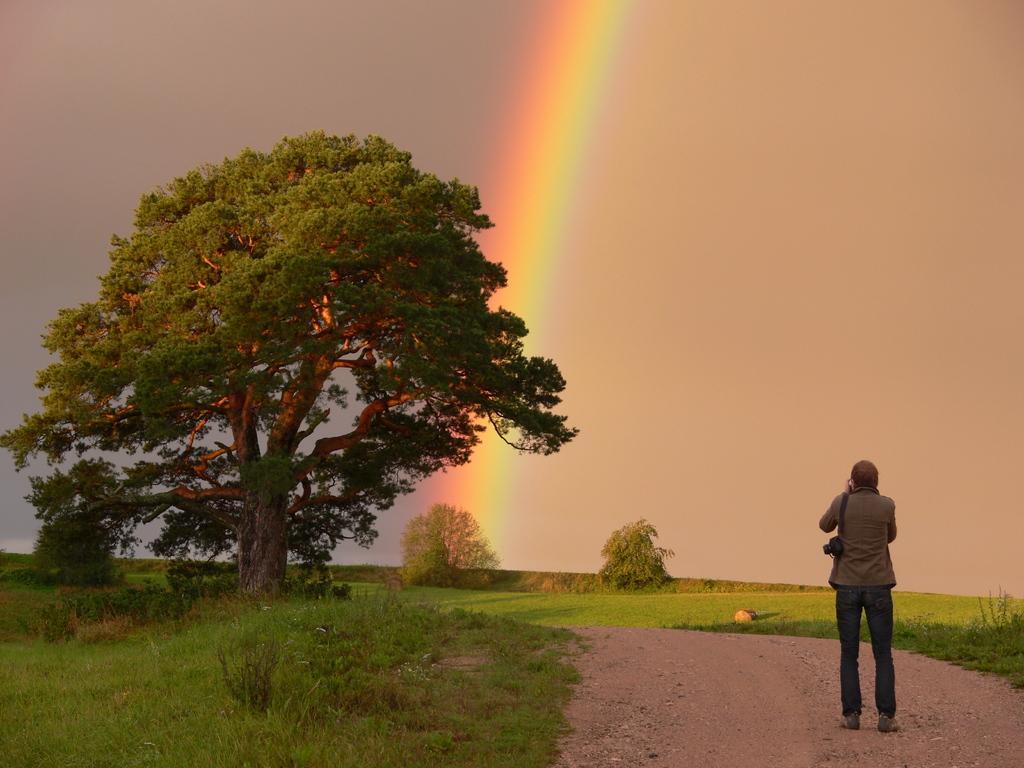Please provide a concise description of this image. Here is a person standing. These are the trees with branches and leaves. Here is the grass and the plants. I can see the rainbow in the sky. 